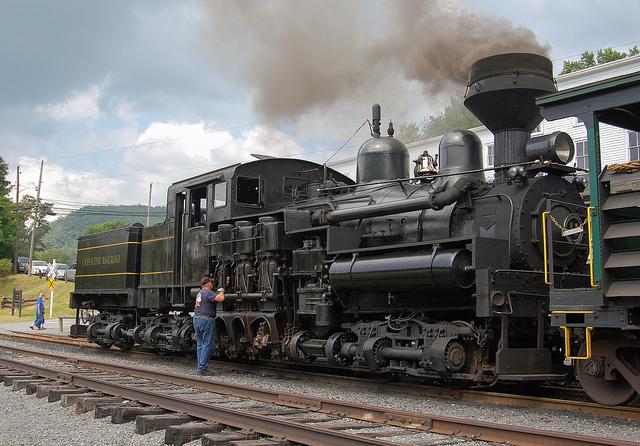Is the left side platform empty?
Give a very brief answer. Yes. What quality is the photo?
Give a very brief answer. Good. How many people near the tracks?
Concise answer only. 2. Is this person pushing the train car?
Give a very brief answer. No. Is this man the driver of this train?
Keep it brief. No. What colors make up the train's paint?
Keep it brief. Black and yellow. Is this train polluting the air?
Concise answer only. Yes. Is the train's headlight on?
Answer briefly. No. What is this person leaning against?
Answer briefly. Train. How many people are by the train?
Be succinct. 2. What color is the smoke coming from the top of the train?
Write a very short answer. Gray. 